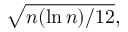Convert formula to latex. <formula><loc_0><loc_0><loc_500><loc_500>{ \sqrt { n ( \ln n ) / 1 2 } } ,</formula> 